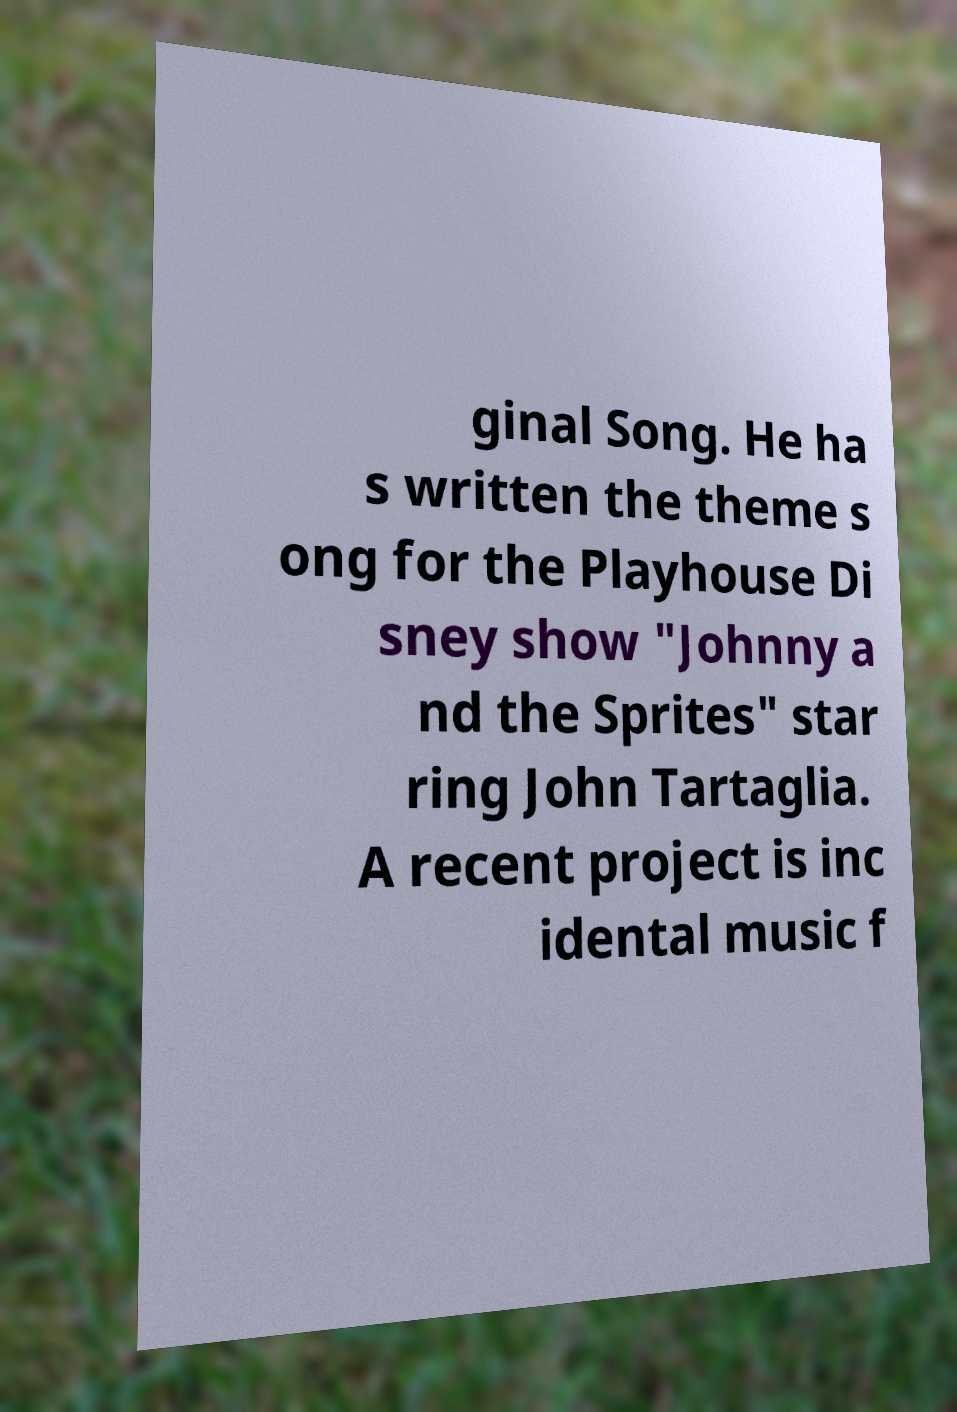Please identify and transcribe the text found in this image. ginal Song. He ha s written the theme s ong for the Playhouse Di sney show "Johnny a nd the Sprites" star ring John Tartaglia. A recent project is inc idental music f 